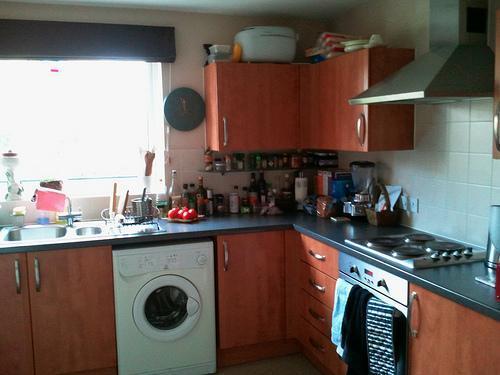How many towels are in the picture?
Give a very brief answer. 3. How many wall cabinets are in the photo?
Give a very brief answer. 2. 